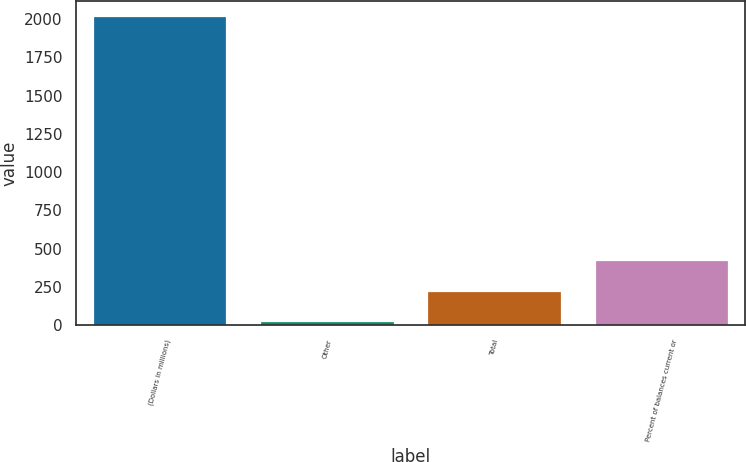Convert chart to OTSL. <chart><loc_0><loc_0><loc_500><loc_500><bar_chart><fcel>(Dollars in millions)<fcel>Other<fcel>Total<fcel>Percent of balances current or<nl><fcel>2017<fcel>28<fcel>226.9<fcel>425.8<nl></chart> 